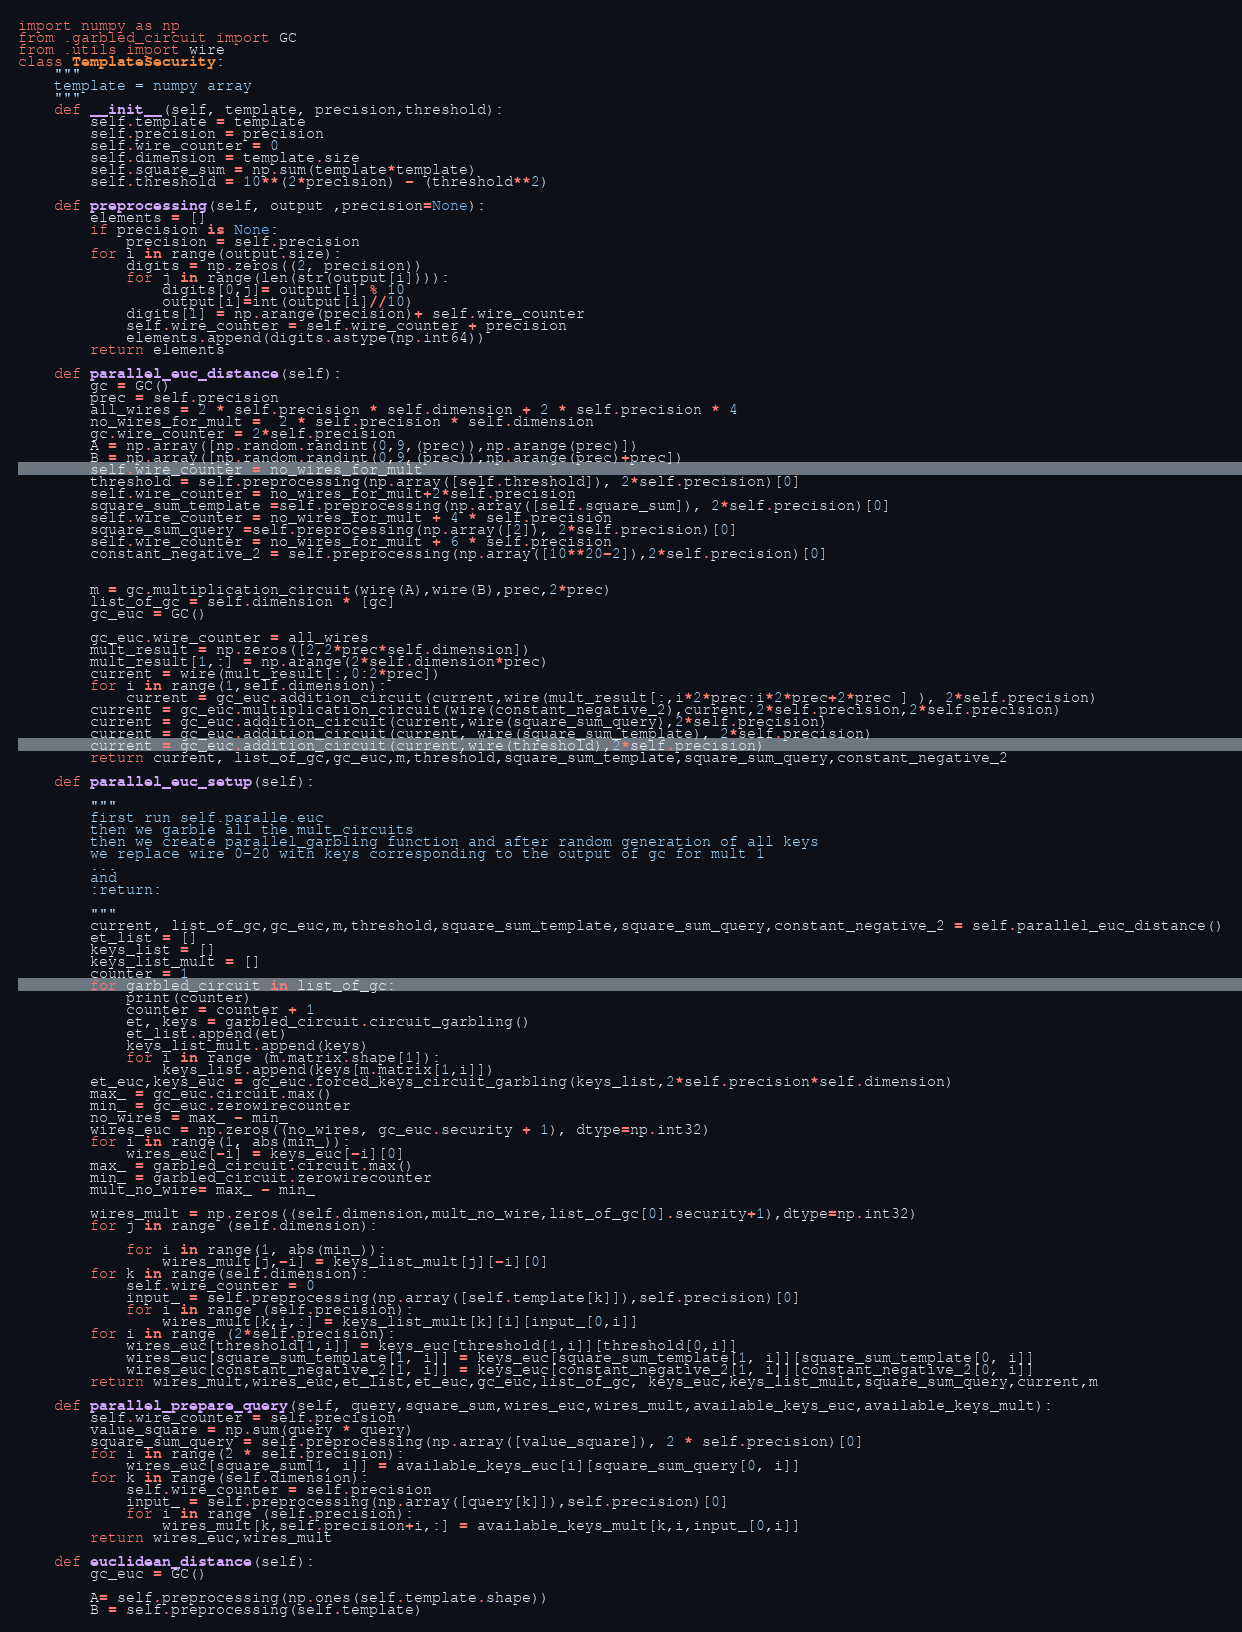Convert code to text. <code><loc_0><loc_0><loc_500><loc_500><_Python_>import numpy as np
from .garbled_circuit import GC
from .utils import wire
class TemplateSecurity:
    """
    template = numpy array
    """
    def __init__(self, template, precision,threshold):
        self.template = template
        self.precision = precision
        self.wire_counter = 0
        self.dimension = template.size
        self.square_sum = np.sum(template*template)
        self.threshold = 10**(2*precision) - (threshold**2)

    def preprocessing(self, output ,precision=None):
        elements = []
        if precision is None:
            precision = self.precision
        for i in range(output.size):
            digits = np.zeros((2, precision))
            for j in range(len(str(output[i]))):
                digits[0,j]= output[i] % 10
                output[i]=int(output[i]//10)
            digits[1] = np.arange(precision)+ self.wire_counter
            self.wire_counter = self.wire_counter + precision
            elements.append(digits.astype(np.int64))
        return elements

    def parallel_euc_distance(self):
        gc = GC()
        prec = self.precision
        all_wires = 2 * self.precision * self.dimension + 2 * self.precision * 4
        no_wires_for_mult =  2 * self.precision * self.dimension
        gc.wire_counter = 2*self.precision
        A = np.array([np.random.randint(0,9,(prec)),np.arange(prec)])
        B = np.array([np.random.randint(0,9,(prec)),np.arange(prec)+prec])
        self.wire_counter = no_wires_for_mult
        threshold = self.preprocessing(np.array([self.threshold]), 2*self.precision)[0]
        self.wire_counter = no_wires_for_mult+2*self.precision
        square_sum_template =self.preprocessing(np.array([self.square_sum]), 2*self.precision)[0]
        self.wire_counter = no_wires_for_mult + 4 * self.precision
        square_sum_query =self.preprocessing(np.array([2]), 2*self.precision)[0]
        self.wire_counter = no_wires_for_mult + 6 * self.precision
        constant_negative_2 = self.preprocessing(np.array([10**20-2]),2*self.precision)[0]


        m = gc.multiplication_circuit(wire(A),wire(B),prec,2*prec)
        list_of_gc = self.dimension * [gc]
        gc_euc = GC()

        gc_euc.wire_counter = all_wires
        mult_result = np.zeros([2,2*prec*self.dimension])
        mult_result[1,:] = np.arange(2*self.dimension*prec)
        current = wire(mult_result[:,0:2*prec])
        for i in range(1,self.dimension):
            current = gc_euc.addition_circuit(current,wire(mult_result[:,i*2*prec:i*2*prec+2*prec ] ), 2*self.precision)
        current = gc_euc.multiplication_circuit(wire(constant_negative_2),current,2*self.precision,2*self.precision)
        current = gc_euc.addition_circuit(current,wire(square_sum_query),2*self.precision)
        current = gc_euc.addition_circuit(current, wire(square_sum_template), 2*self.precision)
        current = gc_euc.addition_circuit(current,wire(threshold),2*self.precision)
        return current, list_of_gc,gc_euc,m,threshold,square_sum_template,square_sum_query,constant_negative_2

    def parallel_euc_setup(self):

        """
        first run self.paralle.euc
        then we garble all the mult_circuits
        then we create parallel_garbling function and after random generation of all keys
        we replace wire 0-20 with keys corresponding to the output of gc for mult 1
        ...
        and
        :return:

        """
        current, list_of_gc,gc_euc,m,threshold,square_sum_template,square_sum_query,constant_negative_2 = self.parallel_euc_distance()
        et_list = []
        keys_list = []
        keys_list_mult = []
        counter = 1
        for garbled_circuit in list_of_gc:
            print(counter)
            counter = counter + 1
            et, keys = garbled_circuit.circuit_garbling()
            et_list.append(et)
            keys_list_mult.append(keys)
            for i in range (m.matrix.shape[1]):
                keys_list.append(keys[m.matrix[1,i]])
        et_euc,keys_euc = gc_euc.forced_keys_circuit_garbling(keys_list,2*self.precision*self.dimension)
        max_ = gc_euc.circuit.max()
        min_ = gc_euc.zerowirecounter
        no_wires = max_ - min_
        wires_euc = np.zeros((no_wires, gc_euc.security + 1), dtype=np.int32)
        for i in range(1, abs(min_)):
            wires_euc[-i] = keys_euc[-i][0]
        max_ = garbled_circuit.circuit.max()
        min_ = garbled_circuit.zerowirecounter
        mult_no_wire= max_ - min_

        wires_mult = np.zeros((self.dimension,mult_no_wire,list_of_gc[0].security+1),dtype=np.int32)
        for j in range (self.dimension):

            for i in range(1, abs(min_)):
                wires_mult[j,-i] = keys_list_mult[j][-i][0]
        for k in range(self.dimension):
            self.wire_counter = 0
            input_ = self.preprocessing(np.array([self.template[k]]),self.precision)[0]
            for i in range (self.precision):
                wires_mult[k,i,:] = keys_list_mult[k][i][input_[0,i]]
        for i in range (2*self.precision):
            wires_euc[threshold[1,i]] = keys_euc[threshold[1,i]][threshold[0,i]]
            wires_euc[square_sum_template[1, i]] = keys_euc[square_sum_template[1, i]][square_sum_template[0, i]]
            wires_euc[constant_negative_2[1, i]] = keys_euc[constant_negative_2[1, i]][constant_negative_2[0, i]]
        return wires_mult,wires_euc,et_list,et_euc,gc_euc,list_of_gc, keys_euc,keys_list_mult,square_sum_query,current,m

    def parallel_prepare_query(self, query,square_sum,wires_euc,wires_mult,available_keys_euc,available_keys_mult):
        self.wire_counter = self.precision
        value_square = np.sum(query * query)
        square_sum_query = self.preprocessing(np.array([value_square]), 2 * self.precision)[0]
        for i in range(2 * self.precision):
            wires_euc[square_sum[1, i]] = available_keys_euc[i][square_sum_query[0, i]]
        for k in range(self.dimension):
            self.wire_counter = self.precision
            input_ = self.preprocessing(np.array([query[k]]),self.precision)[0]
            for i in range (self.precision):
                wires_mult[k,self.precision+i,:] = available_keys_mult[k,i,input_[0,i]]
        return wires_euc,wires_mult

    def euclidean_distance(self):
        gc_euc = GC()

        A= self.preprocessing(np.ones(self.template.shape))
        B = self.preprocessing(self.template)</code> 